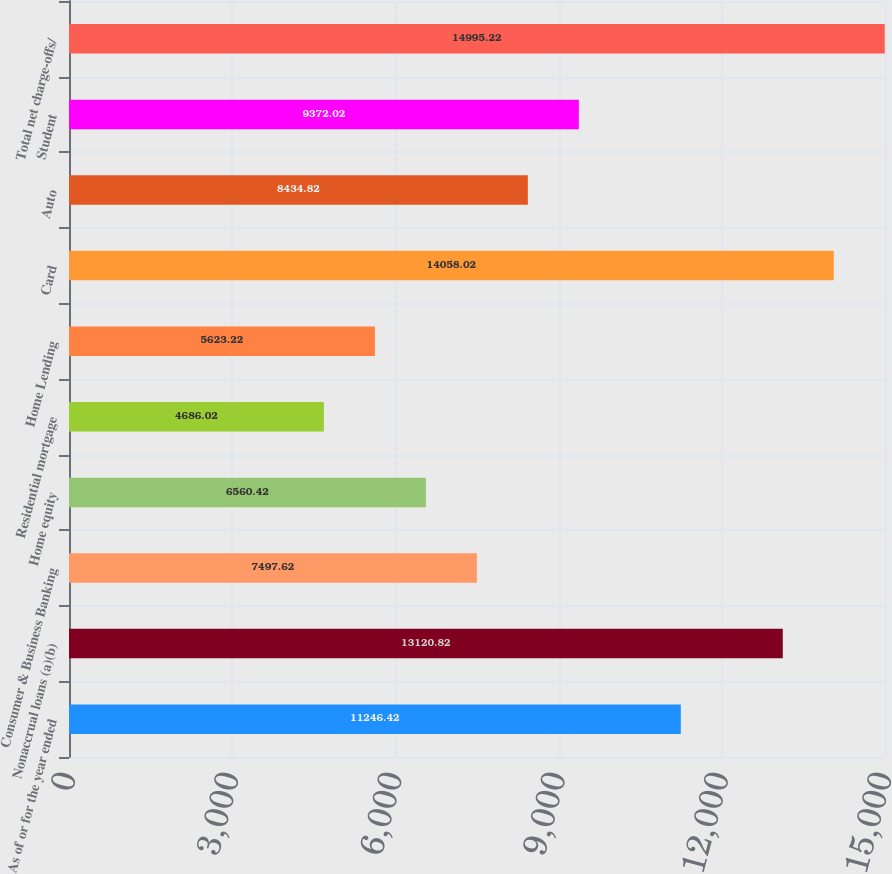Convert chart to OTSL. <chart><loc_0><loc_0><loc_500><loc_500><bar_chart><fcel>As of or for the year ended<fcel>Nonaccrual loans (a)(b)<fcel>Consumer & Business Banking<fcel>Home equity<fcel>Residential mortgage<fcel>Home Lending<fcel>Card<fcel>Auto<fcel>Student<fcel>Total net charge-offs/<nl><fcel>11246.4<fcel>13120.8<fcel>7497.62<fcel>6560.42<fcel>4686.02<fcel>5623.22<fcel>14058<fcel>8434.82<fcel>9372.02<fcel>14995.2<nl></chart> 